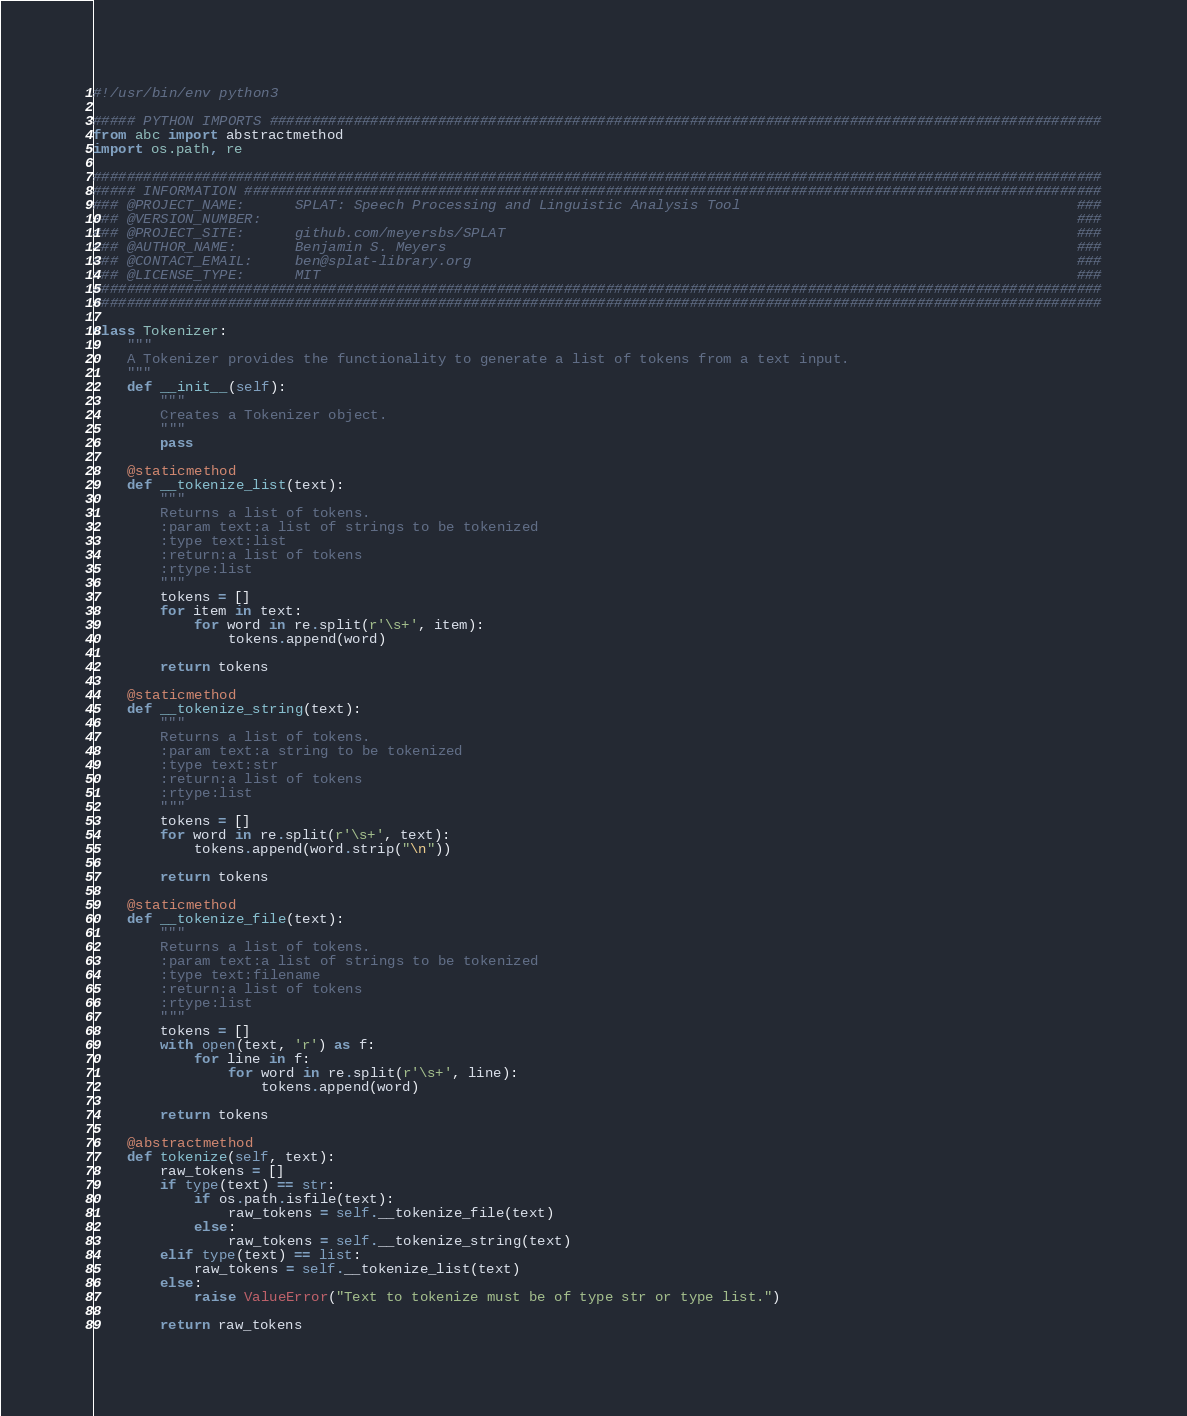<code> <loc_0><loc_0><loc_500><loc_500><_Python_>#!/usr/bin/env python3

##### PYTHON IMPORTS ###################################################################################################
from abc import abstractmethod
import os.path, re

########################################################################################################################
##### INFORMATION ######################################################################################################
### @PROJECT_NAME:		SPLAT: Speech Processing and Linguistic Analysis Tool										 ###
### @VERSION_NUMBER:																								 ###
### @PROJECT_SITE:		github.com/meyersbs/SPLAT																     ###
### @AUTHOR_NAME:		Benjamin S. Meyers																			 ###
### @CONTACT_EMAIL:		ben@splat-library.org																		 ###
### @LICENSE_TYPE:		MIT																							 ###
########################################################################################################################
########################################################################################################################

class Tokenizer:
	"""
	A Tokenizer provides the functionality to generate a list of tokens from a text input.
	"""
	def __init__(self):
		"""
		Creates a Tokenizer object.
		"""
		pass

	@staticmethod
	def __tokenize_list(text):
		"""
		Returns a list of tokens.
		:param text:a list of strings to be tokenized
		:type text:list
		:return:a list of tokens
		:rtype:list
		"""
		tokens = []
		for item in text:
			for word in re.split(r'\s+', item):
				tokens.append(word)

		return tokens

	@staticmethod
	def __tokenize_string(text):
		"""
		Returns a list of tokens.
		:param text:a string to be tokenized
		:type text:str
		:return:a list of tokens
		:rtype:list
		"""
		tokens = []
		for word in re.split(r'\s+', text):
			tokens.append(word.strip("\n"))

		return tokens

	@staticmethod
	def __tokenize_file(text):
		"""
		Returns a list of tokens.
		:param text:a list of strings to be tokenized
		:type text:filename
		:return:a list of tokens
		:rtype:list
		"""
		tokens = []
		with open(text, 'r') as f:
			for line in f:
				for word in re.split(r'\s+', line):
					tokens.append(word)

		return tokens

	@abstractmethod
	def tokenize(self, text):
		raw_tokens = []
		if type(text) == str:
			if os.path.isfile(text):
				raw_tokens = self.__tokenize_file(text)
			else:
				raw_tokens = self.__tokenize_string(text)
		elif type(text) == list:
			raw_tokens = self.__tokenize_list(text)
		else:
			raise ValueError("Text to tokenize must be of type str or type list.")

		return raw_tokens
</code> 